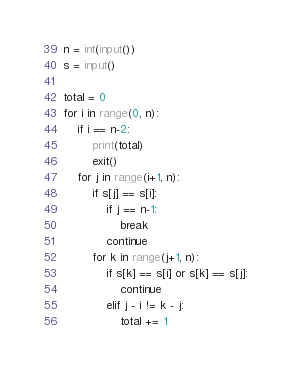<code> <loc_0><loc_0><loc_500><loc_500><_Python_>n = int(input())
s = input()

total = 0
for i in range(0, n):
    if i == n-2:
        print(total)
        exit()
    for j in range(i+1, n):
        if s[j] == s[i]:
            if j == n-1:
                break
            continue
        for k in range(j+1, n):
            if s[k] == s[i] or s[k] == s[j]:
                continue
            elif j - i != k - j:
                total += 1</code> 